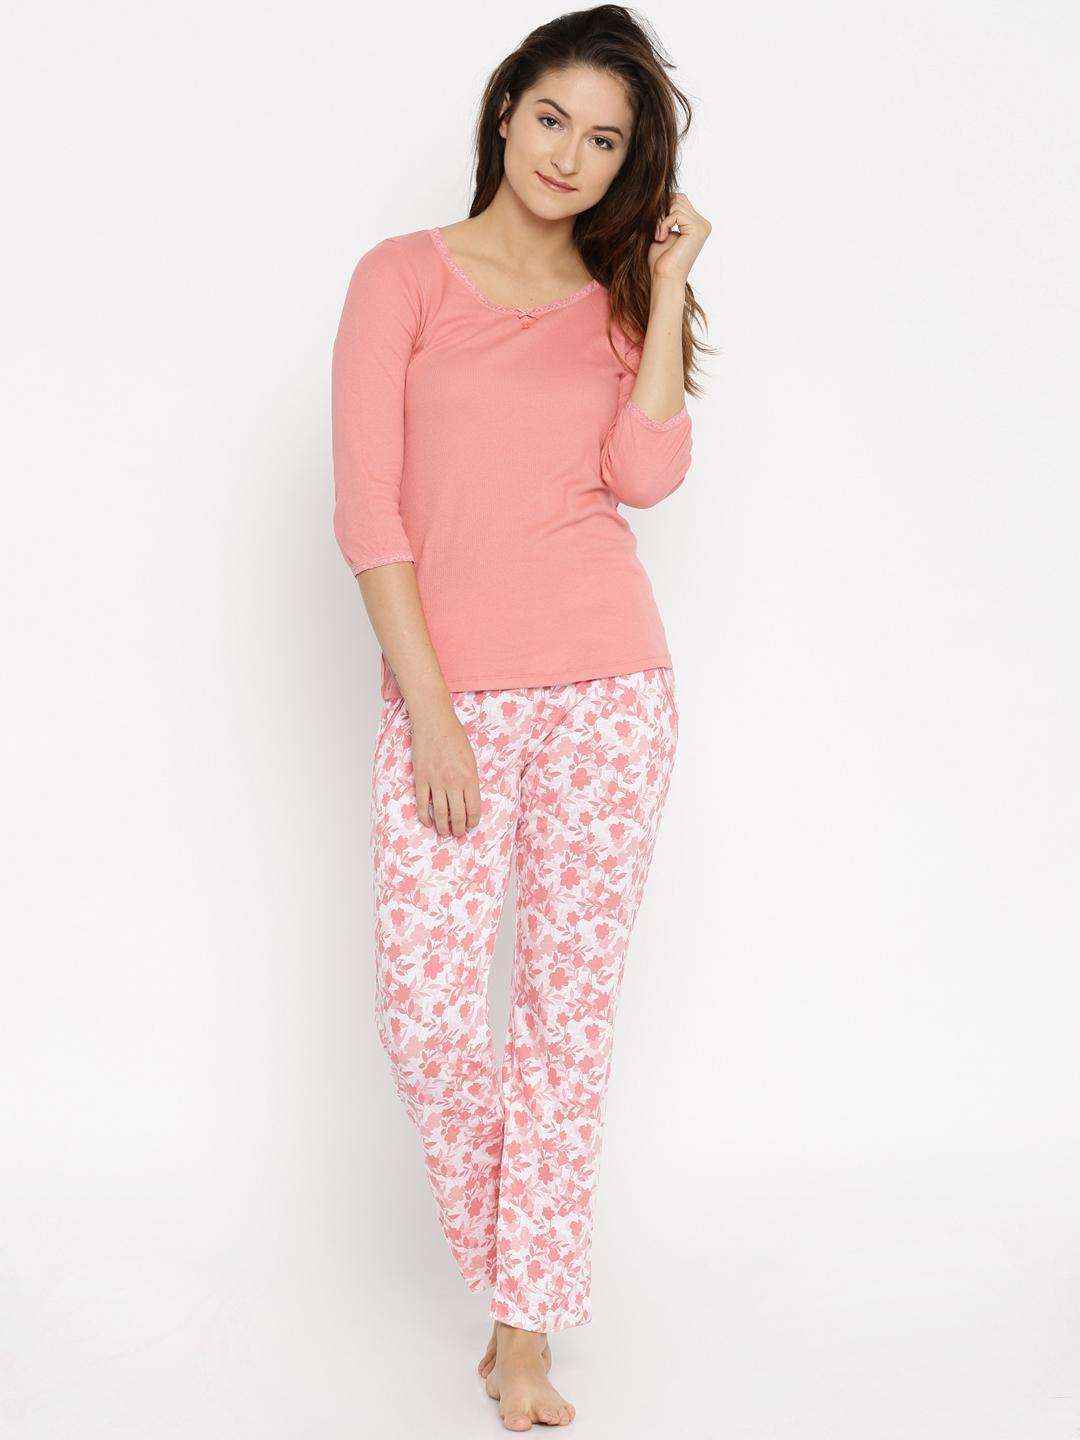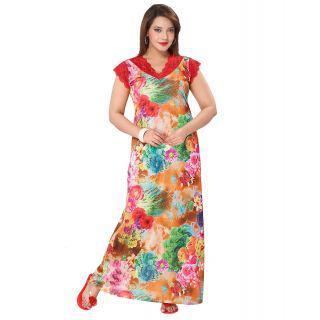The first image is the image on the left, the second image is the image on the right. Assess this claim about the two images: "There is a person with one arm raised so that that hand is approximately level with their shoulder.". Correct or not? Answer yes or no. Yes. 